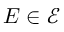Convert formula to latex. <formula><loc_0><loc_0><loc_500><loc_500>E \in { \mathcal { E } }</formula> 